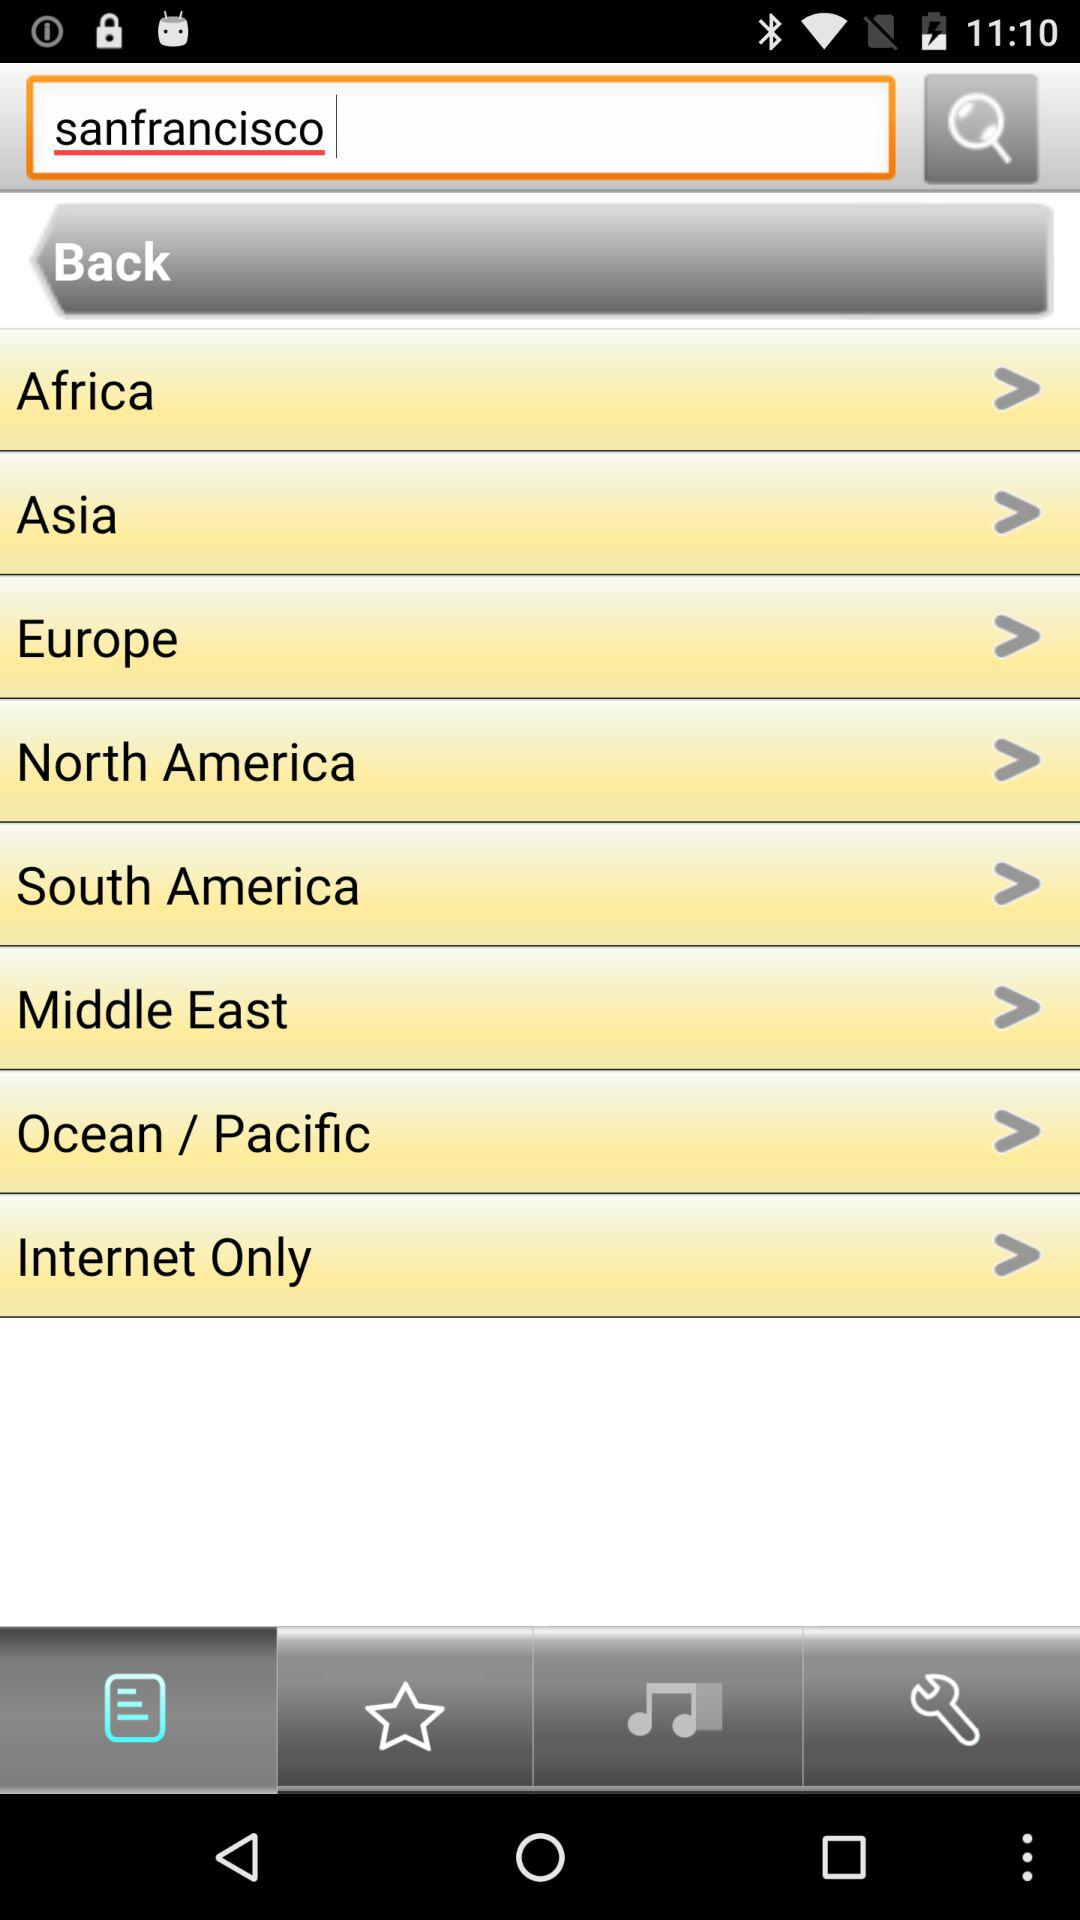What is the location in the search box? The location in the search box is San Francisco. 